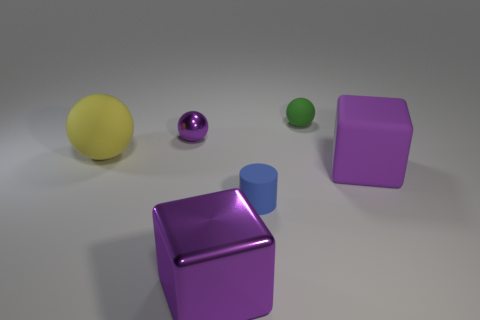Is the number of small yellow metallic things less than the number of big rubber blocks?
Your answer should be very brief. Yes. There is a tiny purple thing that is the same shape as the tiny green thing; what material is it?
Offer a very short reply. Metal. Is the number of cyan shiny things greater than the number of yellow rubber things?
Ensure brevity in your answer.  No. How many other things are there of the same color as the cylinder?
Ensure brevity in your answer.  0. Do the yellow sphere and the large purple thing to the left of the big purple matte block have the same material?
Make the answer very short. No. There is a purple metallic thing in front of the large matte thing that is left of the blue cylinder; how many green objects are on the right side of it?
Give a very brief answer. 1. Is the number of purple spheres behind the small green matte object less than the number of purple things that are behind the blue rubber cylinder?
Ensure brevity in your answer.  Yes. What number of other objects are the same material as the purple sphere?
Keep it short and to the point. 1. What material is the green sphere that is the same size as the blue rubber cylinder?
Ensure brevity in your answer.  Rubber. What number of blue objects are big rubber cylinders or tiny objects?
Offer a very short reply. 1. 